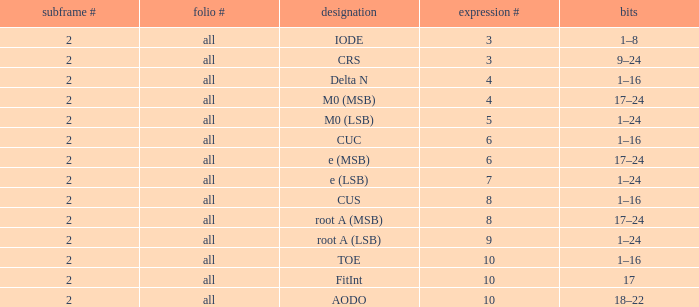What is the page count and word count greater than 5 with Bits of 18–22? All. 